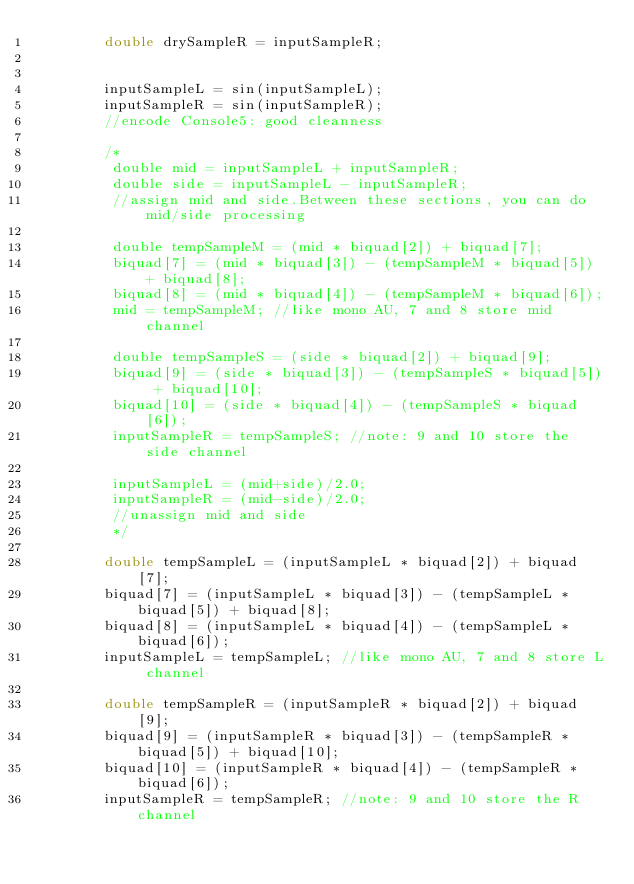Convert code to text. <code><loc_0><loc_0><loc_500><loc_500><_C++_>		double drySampleR = inputSampleR;
		
		
		inputSampleL = sin(inputSampleL);
		inputSampleR = sin(inputSampleR);
		//encode Console5: good cleanness
		
		/*
		 double mid = inputSampleL + inputSampleR;
		 double side = inputSampleL - inputSampleR;
		 //assign mid and side.Between these sections, you can do mid/side processing
		 
		 double tempSampleM = (mid * biquad[2]) + biquad[7];
		 biquad[7] = (mid * biquad[3]) - (tempSampleM * biquad[5]) + biquad[8];
		 biquad[8] = (mid * biquad[4]) - (tempSampleM * biquad[6]);
		 mid = tempSampleM; //like mono AU, 7 and 8 store mid channel
		 
		 double tempSampleS = (side * biquad[2]) + biquad[9];
		 biquad[9] = (side * biquad[3]) - (tempSampleS * biquad[5]) + biquad[10];
		 biquad[10] = (side * biquad[4]) - (tempSampleS * biquad[6]);
		 inputSampleR = tempSampleS; //note: 9 and 10 store the side channel		
		 
		 inputSampleL = (mid+side)/2.0;
		 inputSampleR = (mid-side)/2.0;
		 //unassign mid and side
		 */
		
		double tempSampleL = (inputSampleL * biquad[2]) + biquad[7];
		biquad[7] = (inputSampleL * biquad[3]) - (tempSampleL * biquad[5]) + biquad[8];
		biquad[8] = (inputSampleL * biquad[4]) - (tempSampleL * biquad[6]);
		inputSampleL = tempSampleL; //like mono AU, 7 and 8 store L channel
		
		double tempSampleR = (inputSampleR * biquad[2]) + biquad[9];
		biquad[9] = (inputSampleR * biquad[3]) - (tempSampleR * biquad[5]) + biquad[10];
		biquad[10] = (inputSampleR * biquad[4]) - (tempSampleR * biquad[6]);
		inputSampleR = tempSampleR; //note: 9 and 10 store the R channel
		</code> 